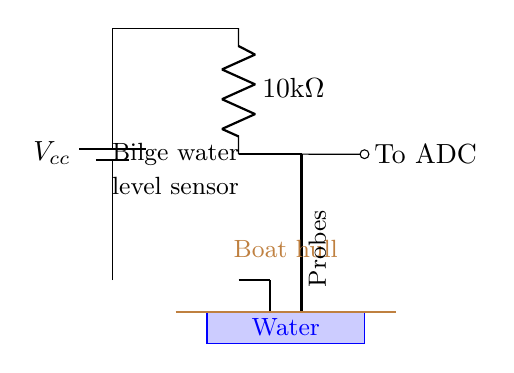What is the power source in this circuit? The power source is a battery, which can be identified as the first component in the circuit diagram, labeled as Vcc.
Answer: Battery What is the resistance value used in the circuit? The resistance value is displayed next to the resistor symbol in the circuit, indicated as 10k ohms.
Answer: 10kΩ What do the two metallic probes represent? The two metallic probes serve as the sensors for detecting the water level, as shown in their connection to the circuit where they interact with the water.
Answer: Probes What happens to the water level if the current path is interrupted? If the current path is interrupted, it indicates that the water level has dropped below the probes, which would prevent a voltage from measuring at the ADC.
Answer: Low water level How does the circuit measure the water level? The circuit uses the resistive properties of the water between the probes to determine the water level, with changes in the voltage being read by the analog-to-digital converter (ADC) connected to the circuit.
Answer: Through resistance measurement What is the function of the ADC in this circuit? The ADC converts the voltage signal corresponding to the water level into a digital format that can be read and processed, allowing for monitoring and alerting of the water level status.
Answer: Digital conversion 